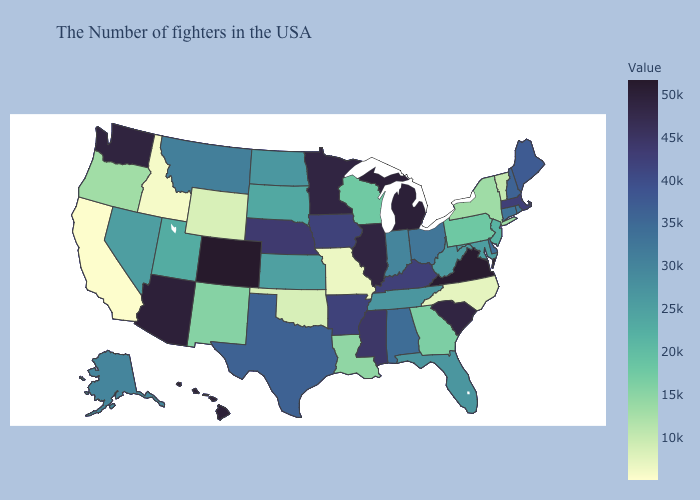Does New York have a lower value than Idaho?
Be succinct. No. Does Oklahoma have the lowest value in the USA?
Answer briefly. No. Does Florida have the lowest value in the USA?
Answer briefly. No. Which states hav the highest value in the Northeast?
Write a very short answer. Massachusetts. Among the states that border Pennsylvania , which have the highest value?
Concise answer only. Delaware. 